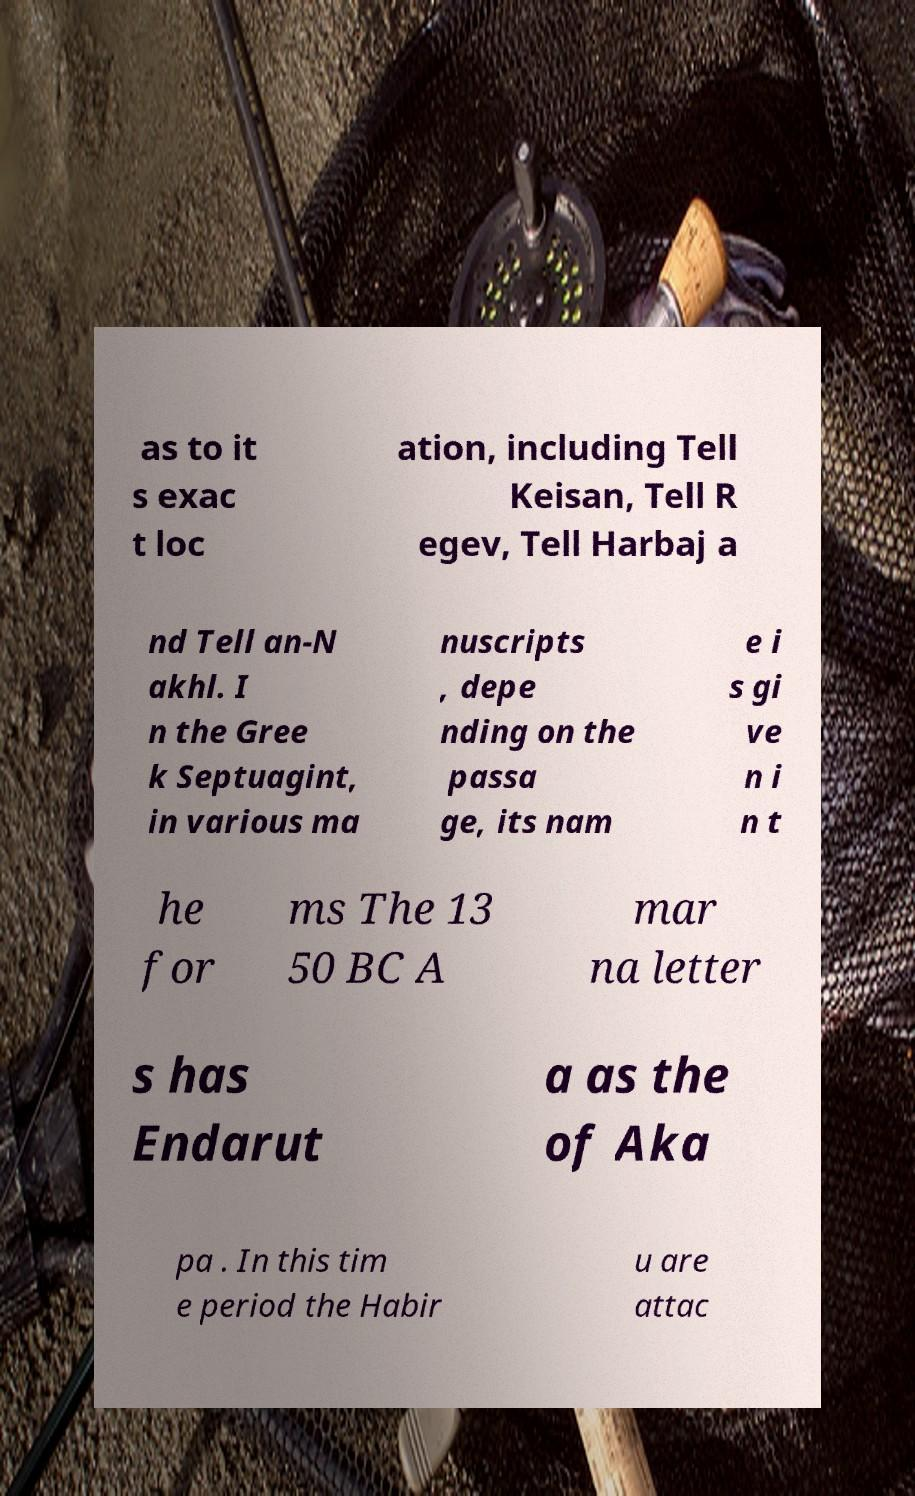Could you extract and type out the text from this image? as to it s exac t loc ation, including Tell Keisan, Tell R egev, Tell Harbaj a nd Tell an-N akhl. I n the Gree k Septuagint, in various ma nuscripts , depe nding on the passa ge, its nam e i s gi ve n i n t he for ms The 13 50 BC A mar na letter s has Endarut a as the of Aka pa . In this tim e period the Habir u are attac 